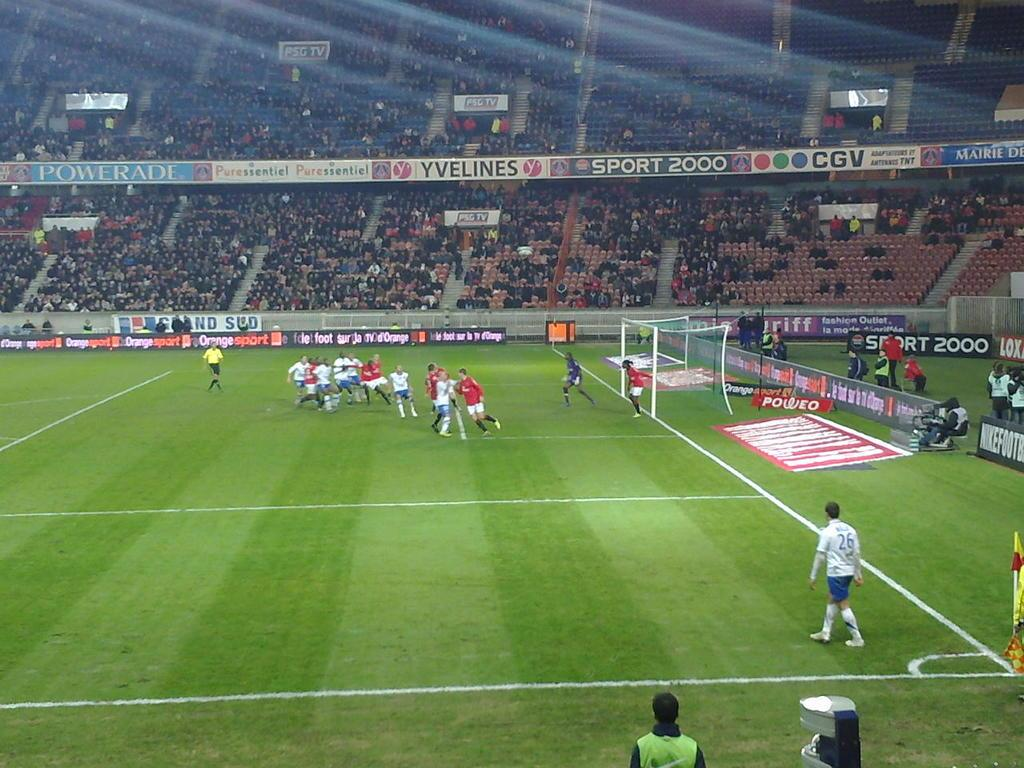<image>
Provide a brief description of the given image. A packet stadium with banners for yvelines and cgv above the stands. 